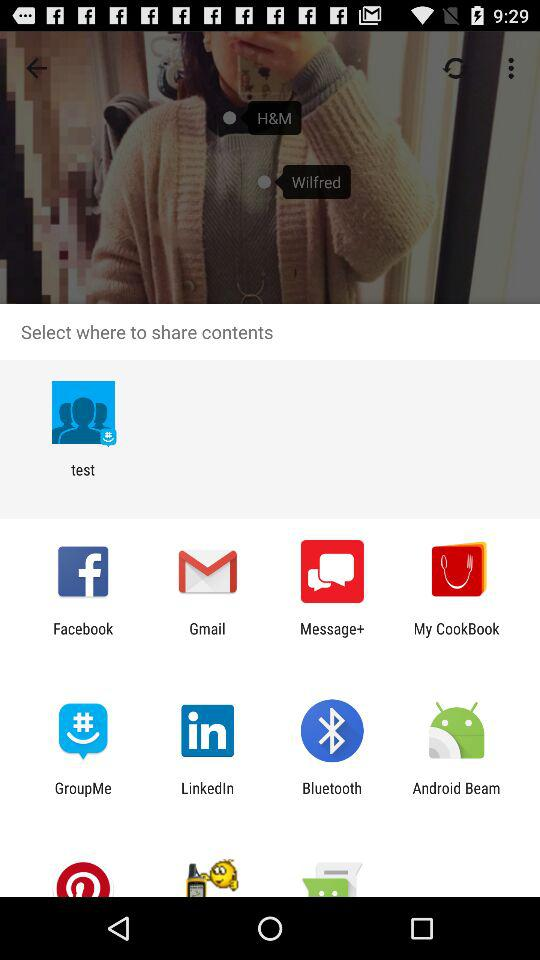What applications can be used to share? The applications that are used to share are "test", "Facebook", "Gmail", "Message+", "My CookBook", "GroupMe", "LinkedIn", "Bluetooth", and "Android Beam". 